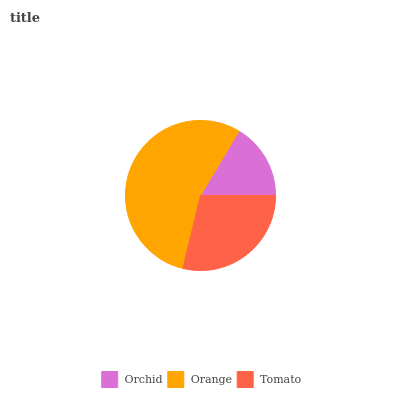Is Orchid the minimum?
Answer yes or no. Yes. Is Orange the maximum?
Answer yes or no. Yes. Is Tomato the minimum?
Answer yes or no. No. Is Tomato the maximum?
Answer yes or no. No. Is Orange greater than Tomato?
Answer yes or no. Yes. Is Tomato less than Orange?
Answer yes or no. Yes. Is Tomato greater than Orange?
Answer yes or no. No. Is Orange less than Tomato?
Answer yes or no. No. Is Tomato the high median?
Answer yes or no. Yes. Is Tomato the low median?
Answer yes or no. Yes. Is Orange the high median?
Answer yes or no. No. Is Orchid the low median?
Answer yes or no. No. 